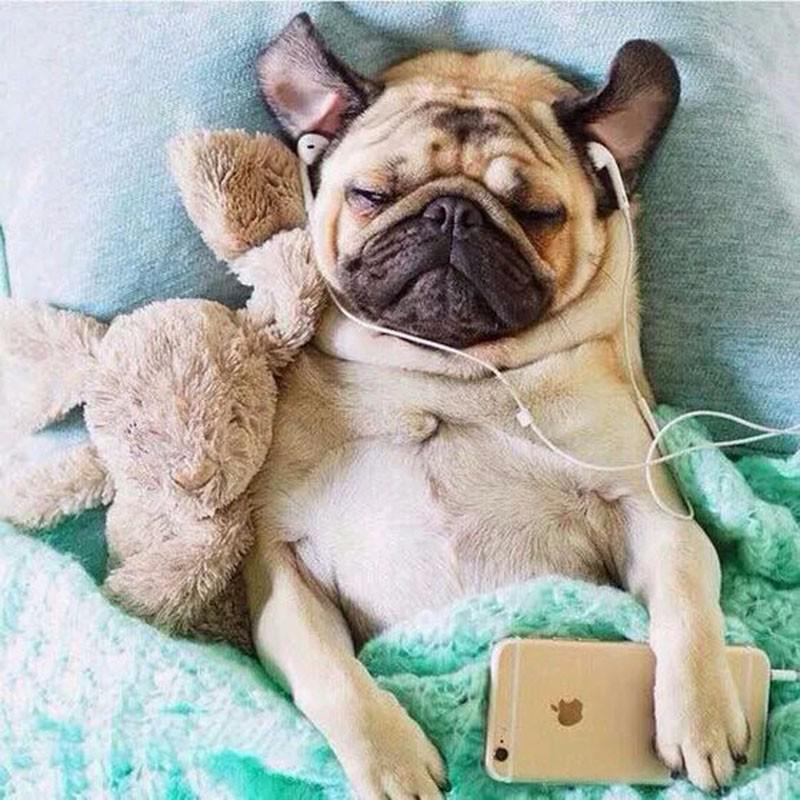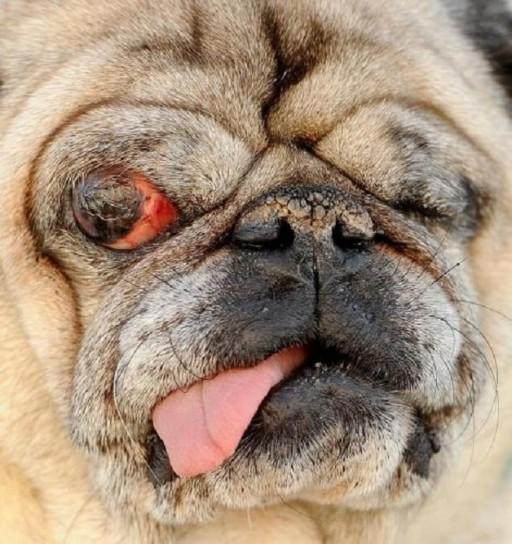The first image is the image on the left, the second image is the image on the right. For the images shown, is this caption "A pug with a dark muzzle is sleeping on a blanket and in contact with something beige and plush in the left image." true? Answer yes or no. Yes. 